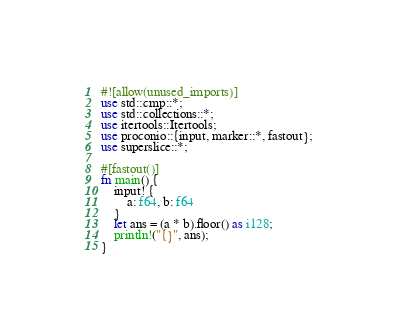Convert code to text. <code><loc_0><loc_0><loc_500><loc_500><_Rust_>#![allow(unused_imports)]
use std::cmp::*;
use std::collections::*;
use itertools::Itertools;
use proconio::{input, marker::*, fastout};
use superslice::*;

#[fastout()]
fn main() {
    input! {
        a: f64, b: f64
    }
    let ans = (a * b).floor() as i128;
    println!("{}", ans);
}
</code> 